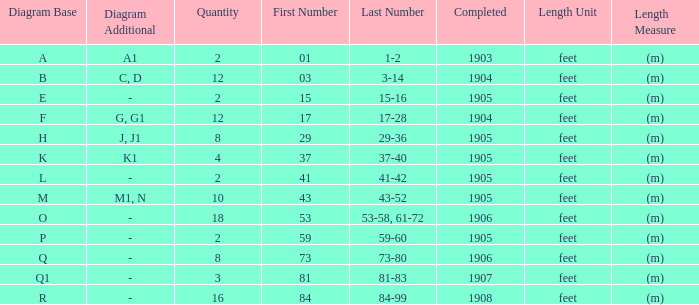What are the numbers for the item completed earlier than 1904? 01 1-2. 